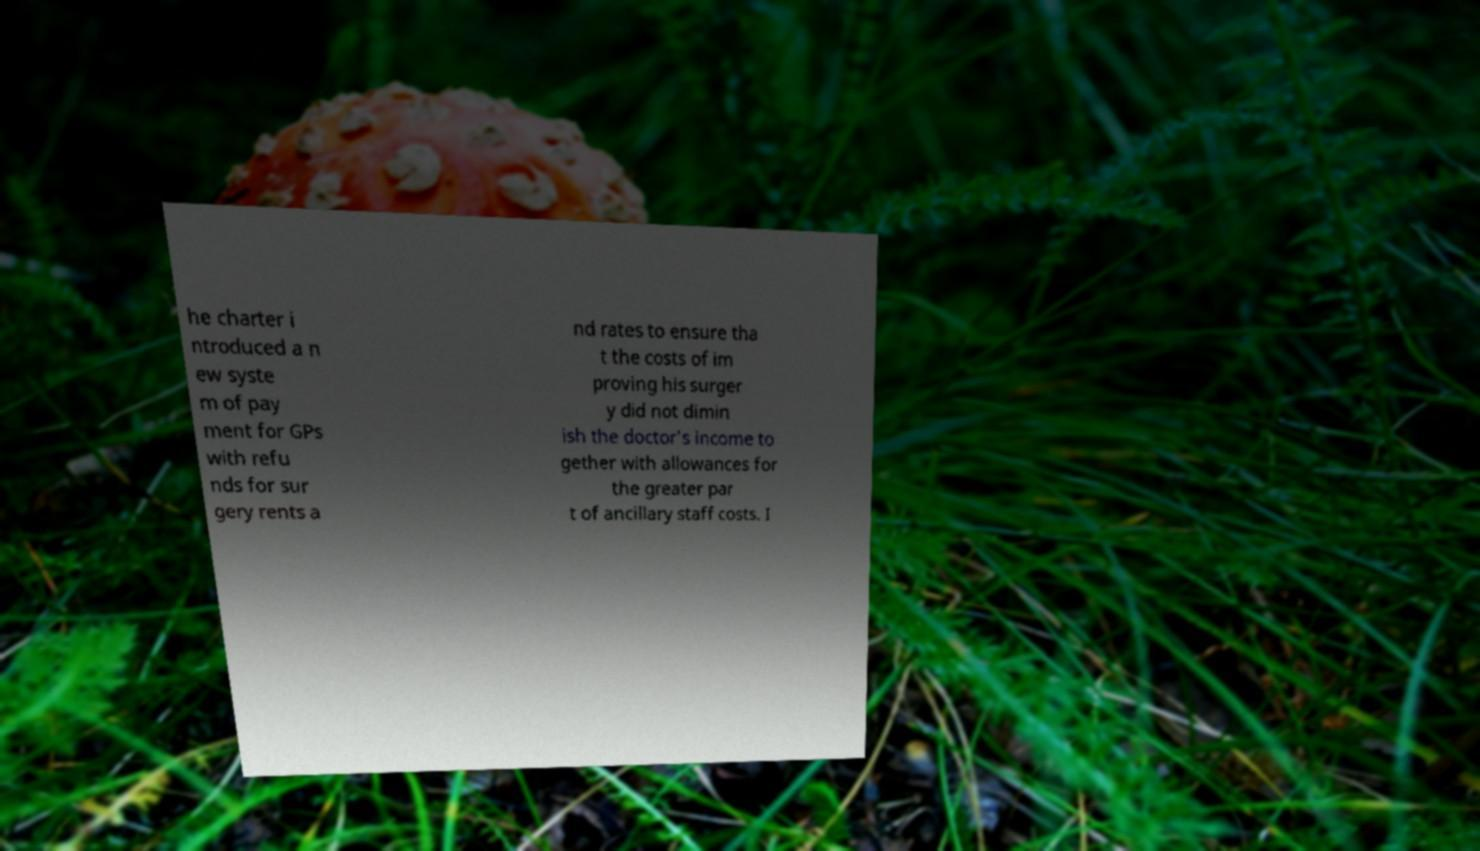I need the written content from this picture converted into text. Can you do that? he charter i ntroduced a n ew syste m of pay ment for GPs with refu nds for sur gery rents a nd rates to ensure tha t the costs of im proving his surger y did not dimin ish the doctor's income to gether with allowances for the greater par t of ancillary staff costs. I 